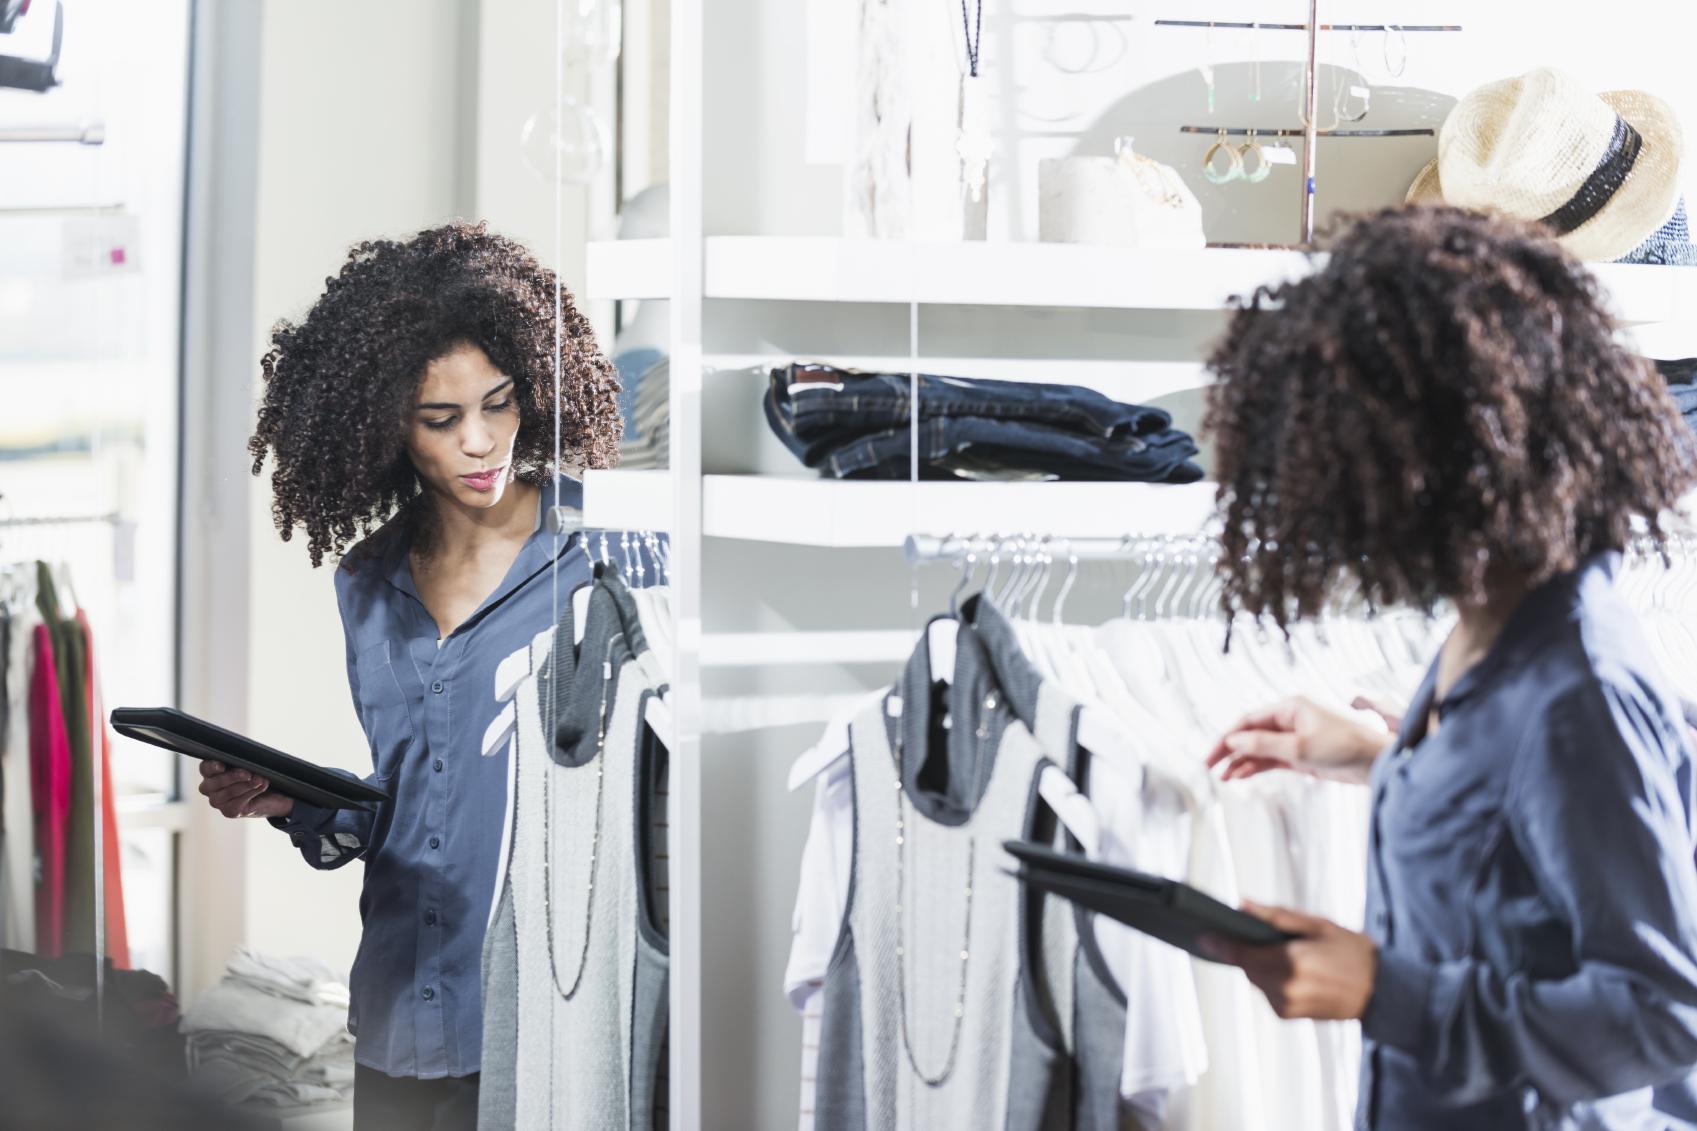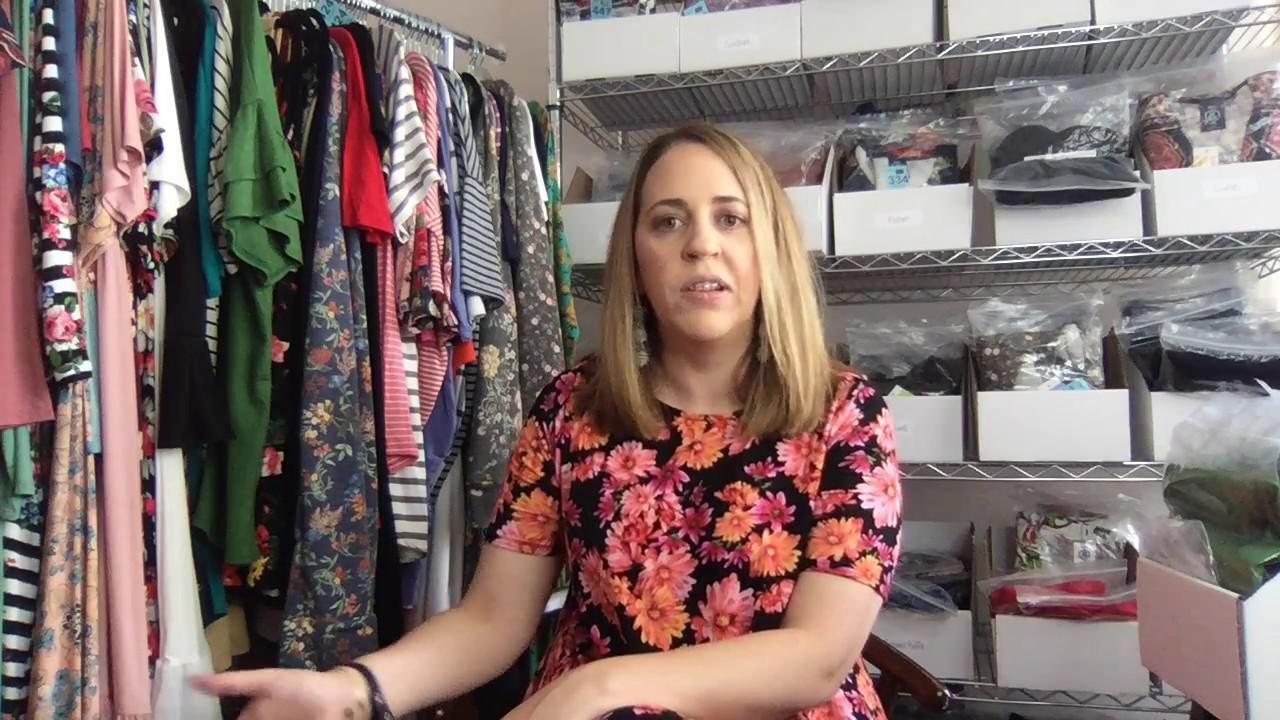The first image is the image on the left, the second image is the image on the right. Examine the images to the left and right. Is the description "The left and right image contains the same number of women." accurate? Answer yes or no. Yes. 